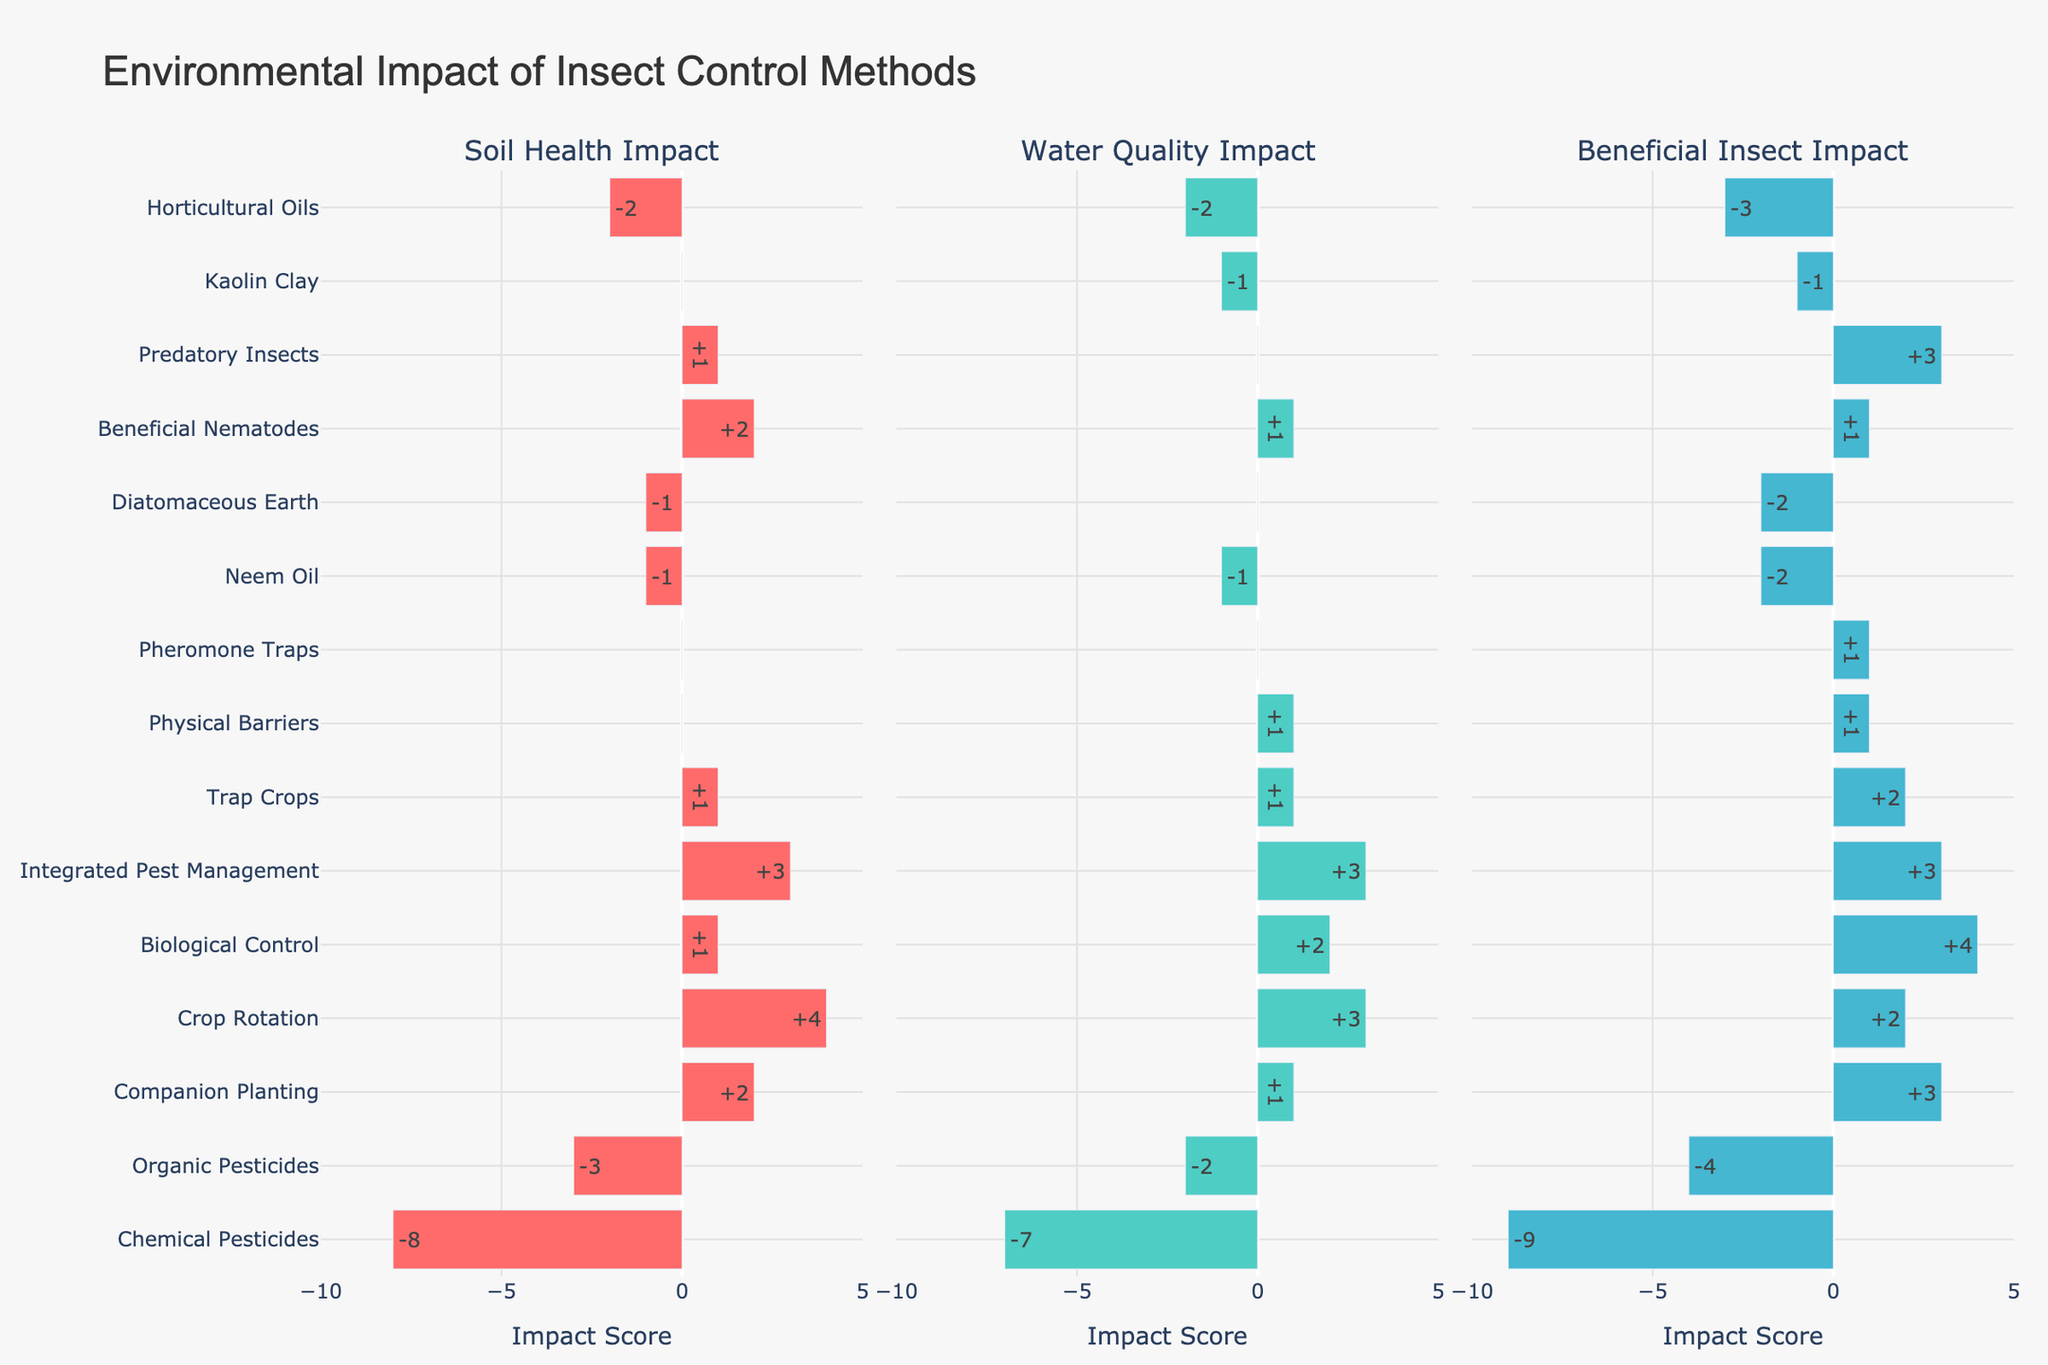Which insect control method has the least negative impact on beneficial insects? The least negative impact on beneficial insects is indicated by the highest bar in the "Beneficial Insect Impact" subplot. Companion Planting has an impact score of +3, which is the highest positive impact score in that category.
Answer: Companion Planting Which method has the most negative impact on soil health? The most negative impact on soil health is represented by the lowest bar in the "Soil Health Impact" subplot. Chemical Pesticides have a soil health impact score of -8, which is the lowest score in that category.
Answer: Chemical Pesticides How do the soil health impacts of using Organic Pesticides compare to that of Neem Oil? Compare the bars for Organic Pesticides and Neem Oil in the "Soil Health Impact" subplot. Organic Pesticides have a score of -3, while Neem Oil has a score of -1. Organic Pesticides have a more negative impact than Neem Oil on soil health.
Answer: Organic Pesticides have a more negative impact What is the total impact score on water quality for methods that have a non-negative impact on soil health? Identify methods with non-negative soil health impact scores and sum their water quality impacts. These methods and their water quality scores are: Companion Planting (+1), Crop Rotation (+3), Biological Control (+2), Integrated Pest Management (+3), Trap Crops (+1), Physical Barriers (+1), Pheromone Traps (0), Beneficial Nematodes (+1), and Predatory Insects (0). Total: 1 + 3 + 2 + 3 + 1 + 1 + 0 + 1 + 0 = 12.
Answer: 12 If you wanted to use a method that has a positive impact on soil health but no impact on water quality, which method would you choose? Look at the "Soil Health Impact" and "Water Quality Impact" subplots. Predatory Insects have a soil health impact score of +1 and a water quality impact score of 0. Therefore, the method should be Predatory Insects.
Answer: Predatory Insects Which two methods have the same impact score across all three categories, and what is that score? Look at the bars for each method in all three subplots. Integrated Pest Management has an impact score of +3 in all categories. No other method has the same score across all three categories.
Answer: Integrated Pest Management; +3 How do the beneficial insect impacts of Physical Barriers compare to those of Kaolin Clay? Compare the bars for Physical Barriers and Kaolin Clay in the "Beneficial Insect Impact" subplot. Physical Barriers have a score of +1, while Kaolin Clay has a score of -1. Hence, Physical Barriers have a more positive impact compared to Kaolin Clay.
Answer: Physical Barriers are more positive Which method has the maximum positive impact on soil health? Identify the method with the highest bar in the "Soil Health Impact" subplot. Crop Rotation has the highest positive impact score of +4.
Answer: Crop Rotation 